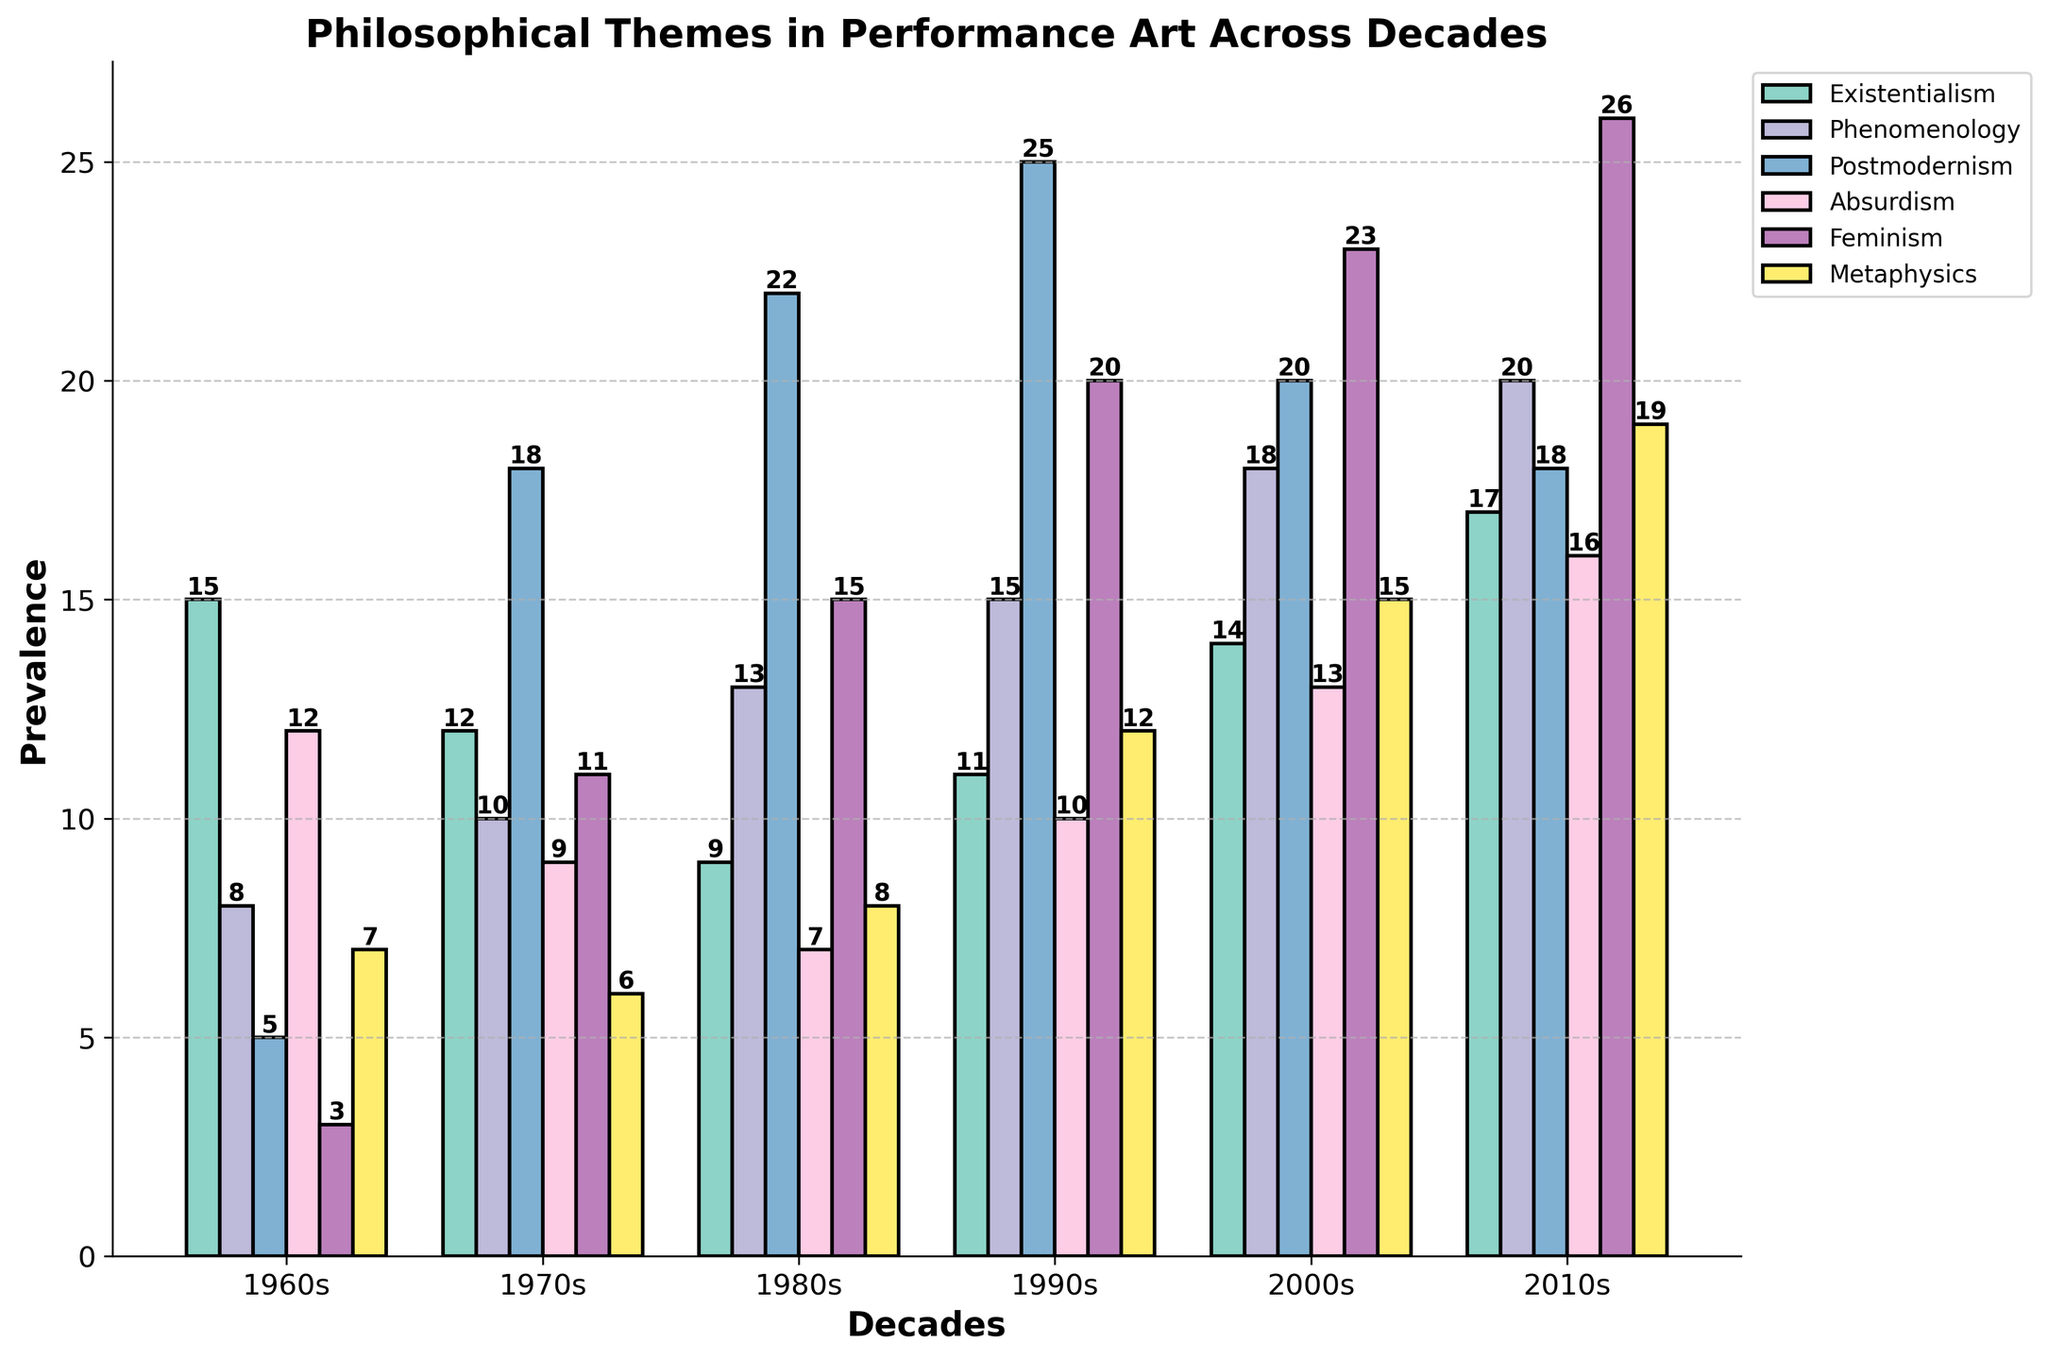Which philosophical theme had the highest prevalence in the 2010s? The bar for Feminism is the tallest in the category of the 2010s.
Answer: Feminism Which decade saw the greatest prevalence of Postmodernism? The bar height is the tallest for Postmodernism in the 1990s compared to other decades.
Answer: 1990s What is the difference in the prevalence of Absurdism between the 1960s and the 2010s? The heights of the bars for Absurdism are 12 in the 1960s and 16 in the 2010s. The difference is 16 - 12.
Answer: 4 Which philosophical theme has consistently increased in prevalence from the 1960s to the 2010s? Feminism has shown a consistent increase in the height of its bars from 3 in the 1960s to 26 in the 2010s.
Answer: Feminism In which decade did Metaphysics have the lowest prevalence? The shortest bar for Metaphysics is visible in the 1970s with a height of 6.
Answer: 1970s What is the average prevalence of Existentialism across all decades? Sum the heights of the bars of Existentialism for all decades (15 + 12 + 9 + 11 + 14 + 17) and divide by the number of decades (6). (15 + 12 + 9 + 11 + 14 + 17) / 6 = 78 / 6.
Answer: 13 Which decade had the most balanced prevalence across all philosophical themes? By checking the similarity in bar heights, we see the 2000s show relatively balanced bars across themes with values 14, 18, 20, 13, 23, and 15.
Answer: 2000s How much did the prevalence of Phenomenology increase from the 1960s to the 2010s? The bars for Phenomenology rose from 8 in the 1960s to 20 in the 2010s. The increase is 20 - 8.
Answer: 12 Which philosophical theme had the second highest prevalence in the 2000s? Feminism has the highest bar at 23 in the 2000s, and Metaphysics is the second highest at 15.
Answer: Metaphysics Compare the prevalence of Existentialism and Absurdism in the 1980s. Which was more prevalent? The bar height for Existentialism in the 1980s is 9, while for Absurdism it is 7. Existentialism has a taller bar.
Answer: Existentialism 